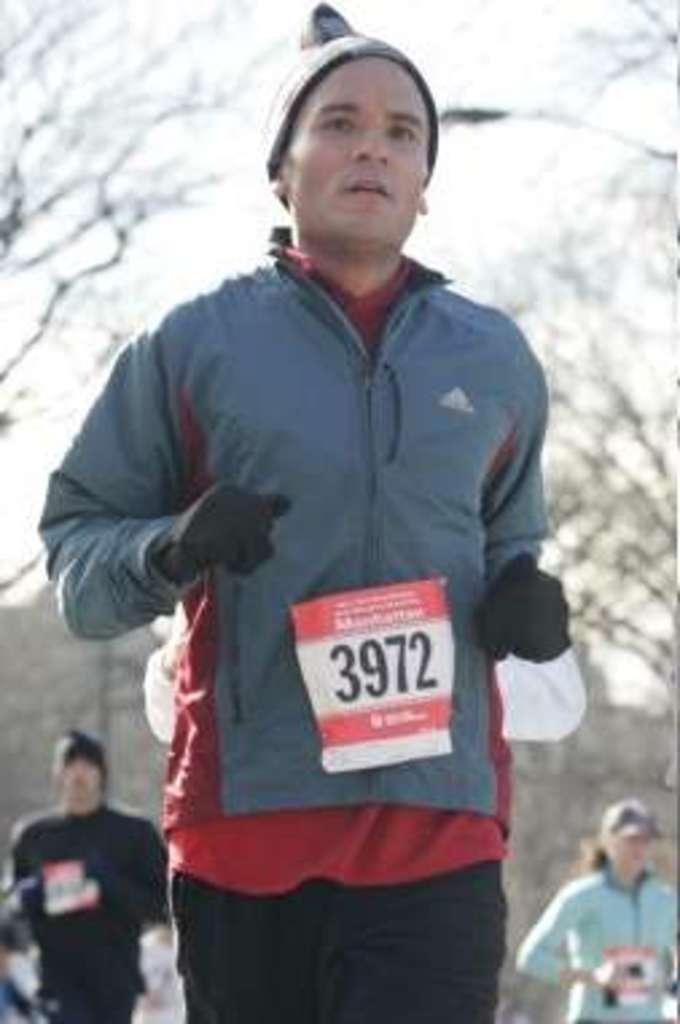Can you describe this image briefly? In this image, there are three persons standing. In the background, I can see the trees and the sky. 